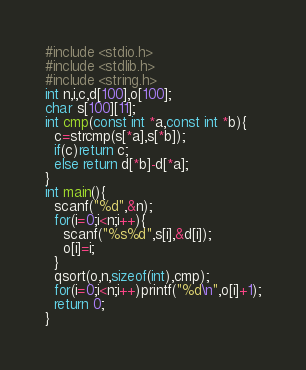Convert code to text. <code><loc_0><loc_0><loc_500><loc_500><_C_>#include <stdio.h>
#include <stdlib.h>
#include <string.h>
int n,i,c,d[100],o[100];
char s[100][11];
int cmp(const int *a,const int *b){
  c=strcmp(s[*a],s[*b]);
  if(c)return c;
  else return d[*b]-d[*a];
}
int main(){
  scanf("%d",&n);
  for(i=0;i<n;i++){
    scanf("%s%d",s[i],&d[i]);
    o[i]=i;
  }
  qsort(o,n,sizeof(int),cmp);
  for(i=0;i<n;i++)printf("%d\n",o[i]+1);
  return 0;
}</code> 